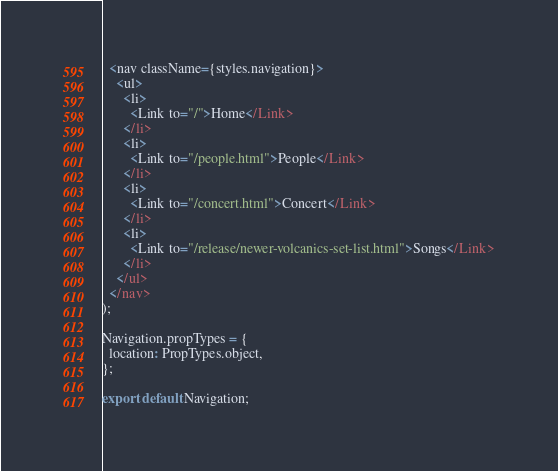<code> <loc_0><loc_0><loc_500><loc_500><_JavaScript_>  <nav className={styles.navigation}>
    <ul>
      <li>
        <Link to="/">Home</Link>
      </li>
      <li>
        <Link to="/people.html">People</Link>
      </li>
      <li>
        <Link to="/concert.html">Concert</Link>
      </li>
      <li>
        <Link to="/release/newer-volcanics-set-list.html">Songs</Link>
      </li>
    </ul>
  </nav>
);

Navigation.propTypes = {
  location: PropTypes.object,
};

export default Navigation;
</code> 